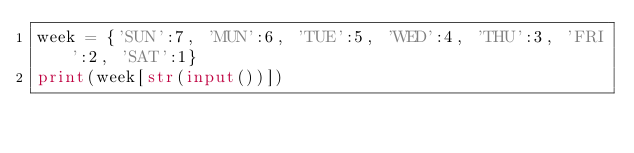<code> <loc_0><loc_0><loc_500><loc_500><_Python_>week = {'SUN':7, 'MUN':6, 'TUE':5, 'WED':4, 'THU':3, 'FRI':2, 'SAT':1}
print(week[str(input())])</code> 